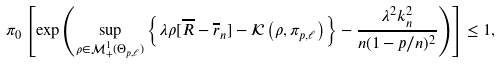<formula> <loc_0><loc_0><loc_500><loc_500>\pi _ { 0 } \left [ \exp \left ( \sup _ { \rho \in \mathcal { M } _ { + } ^ { 1 } ( \Theta _ { p , \ell } ) } \left \{ \lambda \rho [ \overline { R } - \overline { r } _ { n } ] - \mathcal { K } \left ( \rho , \pi _ { p , \ell } \right ) \right \} - \frac { \lambda ^ { 2 } k _ { n } ^ { 2 } } { n ( 1 - p / n ) ^ { 2 } } \right ) \right ] \leq 1 ,</formula> 